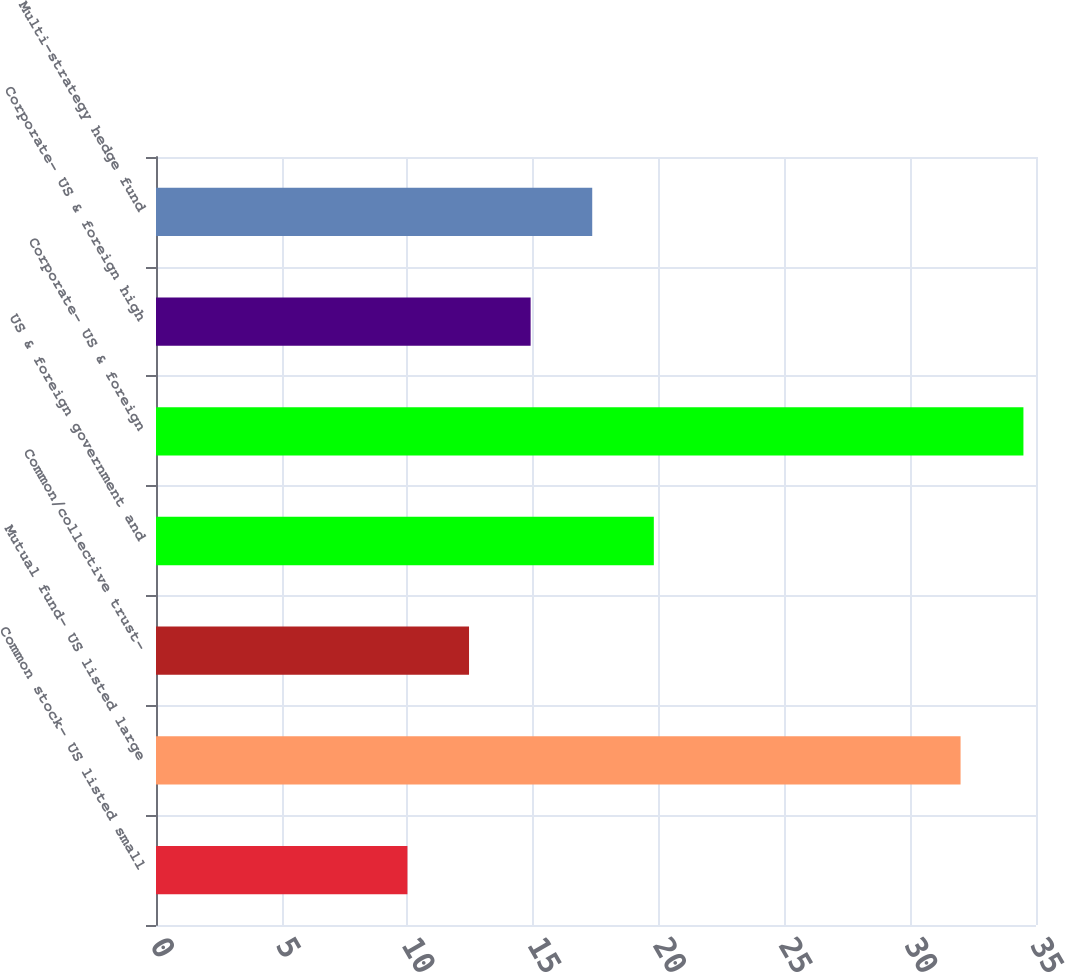<chart> <loc_0><loc_0><loc_500><loc_500><bar_chart><fcel>Common stock- US listed small<fcel>Mutual fund- US listed large<fcel>Common/collective trust-<fcel>US & foreign government and<fcel>Corporate- US & foreign<fcel>Corporate- US & foreign high<fcel>Multi-strategy hedge fund<nl><fcel>10<fcel>32<fcel>12.45<fcel>19.8<fcel>34.5<fcel>14.9<fcel>17.35<nl></chart> 